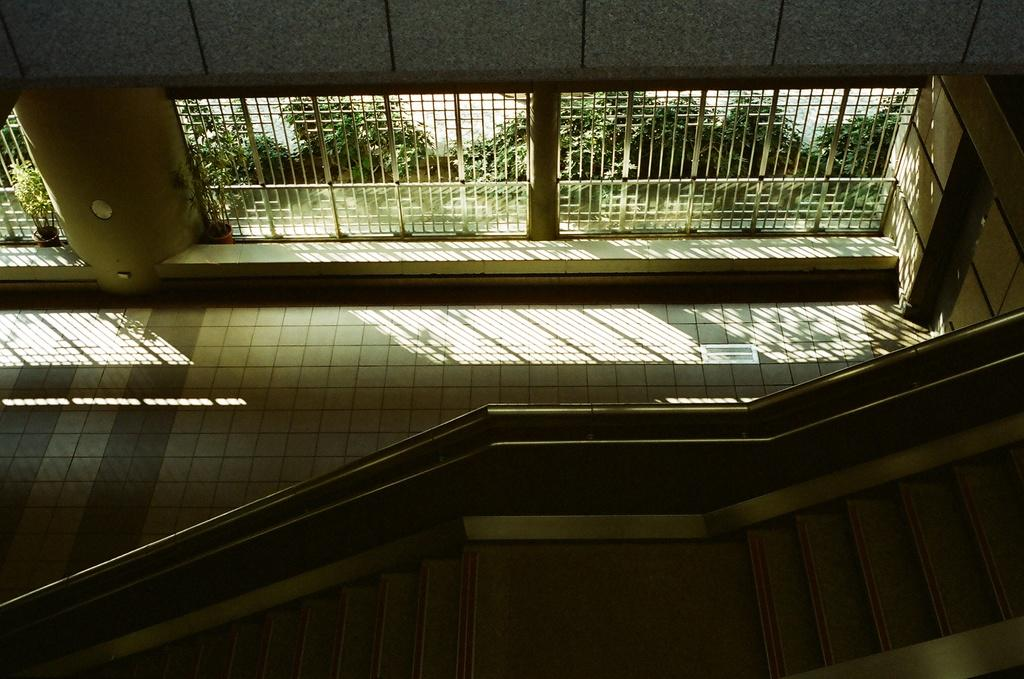What part of a building is shown in the image? The image shows the inner part of a building. What architectural feature can be seen in the image? There are stairs in the image. What can be seen through the windows in the image? There are windows in the image, but the view through them is not specified. What structural elements support the building in the image? There are pillars in the image. What decorative items are present in the image? There are flower pots in the image. What type of vegetation is visible in the image? There are trees in the image. What type of birds can be seen flying through the smoke in the image? There is no smoke or birds present in the image. 